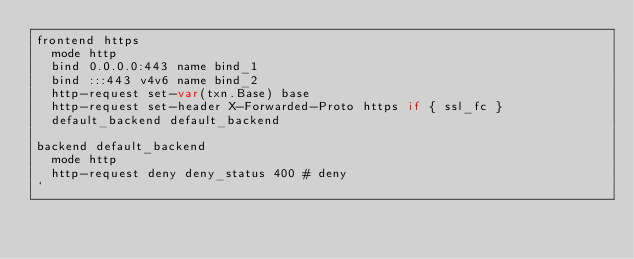Convert code to text. <code><loc_0><loc_0><loc_500><loc_500><_Go_>frontend https 
  mode http
  bind 0.0.0.0:443 name bind_1
  bind :::443 v4v6 name bind_2
  http-request set-var(txn.Base) base
  http-request set-header X-Forwarded-Proto https if { ssl_fc }
  default_backend default_backend

backend default_backend 
  mode http
  http-request deny deny_status 400 # deny
`
</code> 